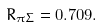<formula> <loc_0><loc_0><loc_500><loc_500>R _ { \pi \Sigma } = 0 . 7 0 9 .</formula> 